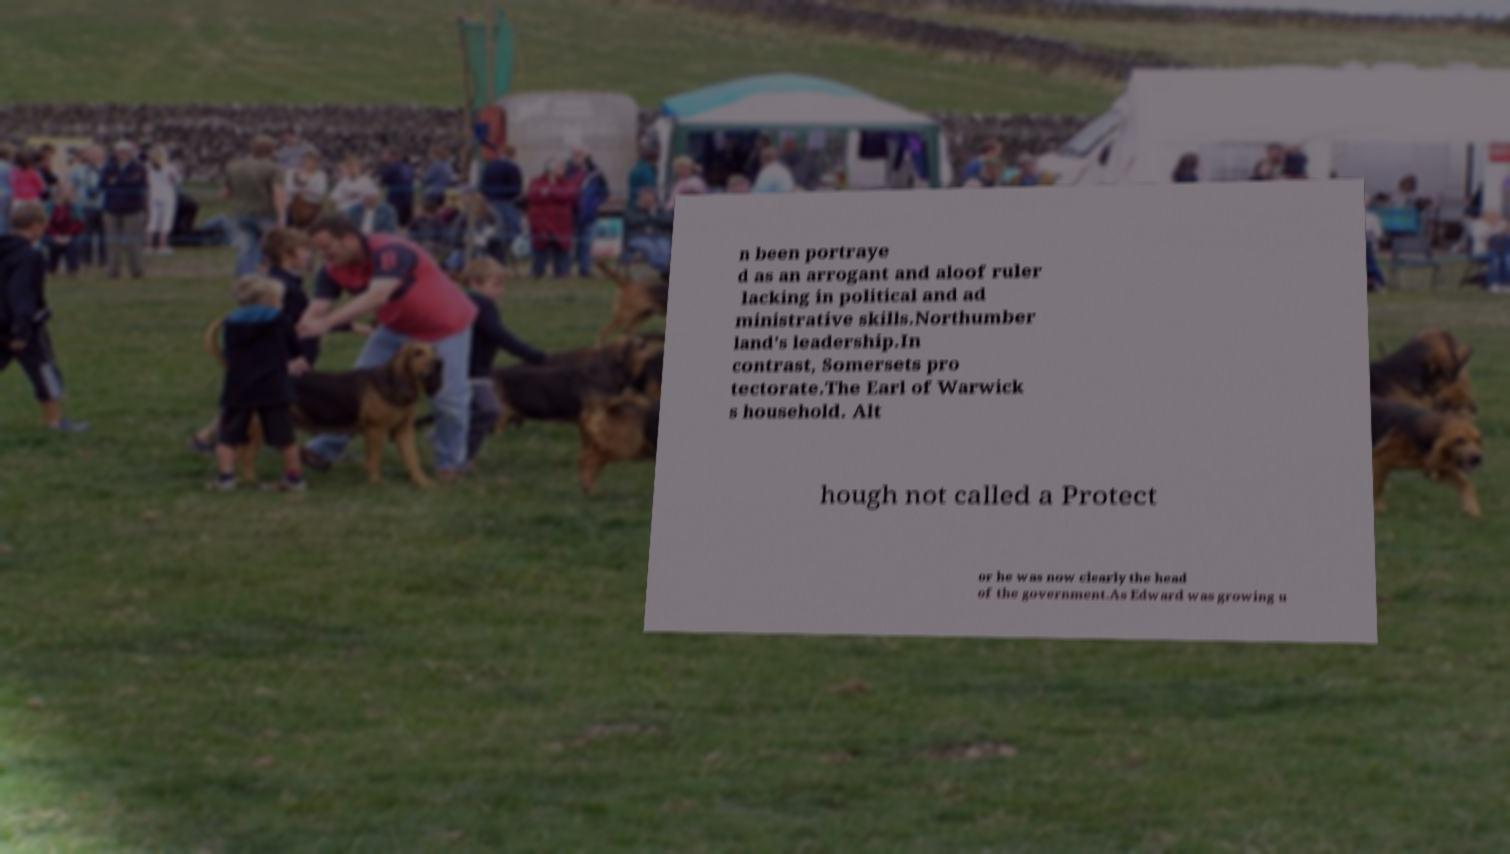What messages or text are displayed in this image? I need them in a readable, typed format. n been portraye d as an arrogant and aloof ruler lacking in political and ad ministrative skills.Northumber land's leadership.In contrast, Somersets pro tectorate.The Earl of Warwick s household. Alt hough not called a Protect or he was now clearly the head of the government.As Edward was growing u 